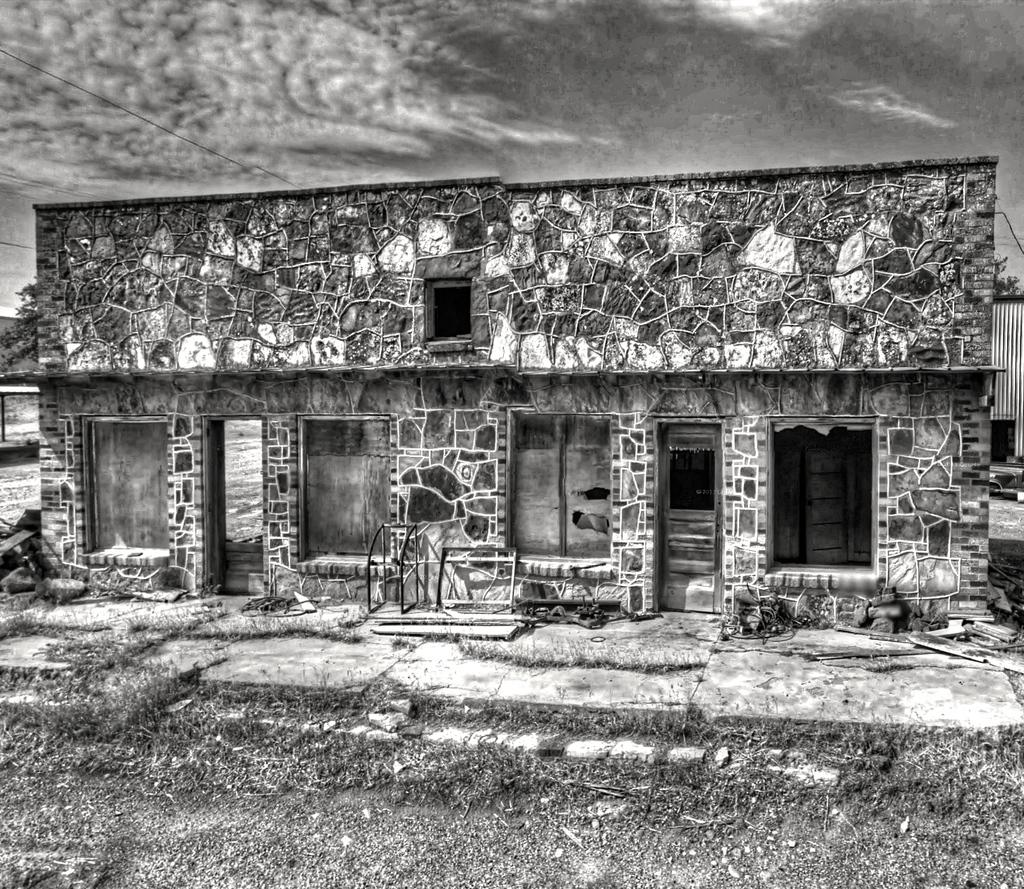What type of structure is visible in the image? There is a building in the image. What is on the ground in the image? There is grass on the ground in the image. What can be seen in the background of the image? The sky is visible in the background of the image. What is the condition of the sky in the image? Clouds are present in the sky. What is the color scheme of the image? The image is black and white. Where is the shelf located in the image? There is no shelf present in the image. What type of chalk can be seen on the ground in the image? There is no chalk present in the image. 